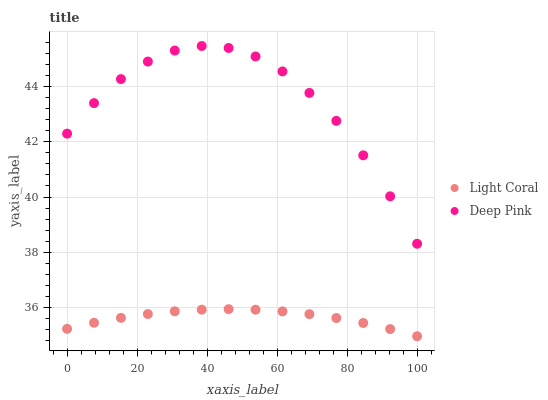Does Light Coral have the minimum area under the curve?
Answer yes or no. Yes. Does Deep Pink have the maximum area under the curve?
Answer yes or no. Yes. Does Deep Pink have the minimum area under the curve?
Answer yes or no. No. Is Light Coral the smoothest?
Answer yes or no. Yes. Is Deep Pink the roughest?
Answer yes or no. Yes. Is Deep Pink the smoothest?
Answer yes or no. No. Does Light Coral have the lowest value?
Answer yes or no. Yes. Does Deep Pink have the lowest value?
Answer yes or no. No. Does Deep Pink have the highest value?
Answer yes or no. Yes. Is Light Coral less than Deep Pink?
Answer yes or no. Yes. Is Deep Pink greater than Light Coral?
Answer yes or no. Yes. Does Light Coral intersect Deep Pink?
Answer yes or no. No. 